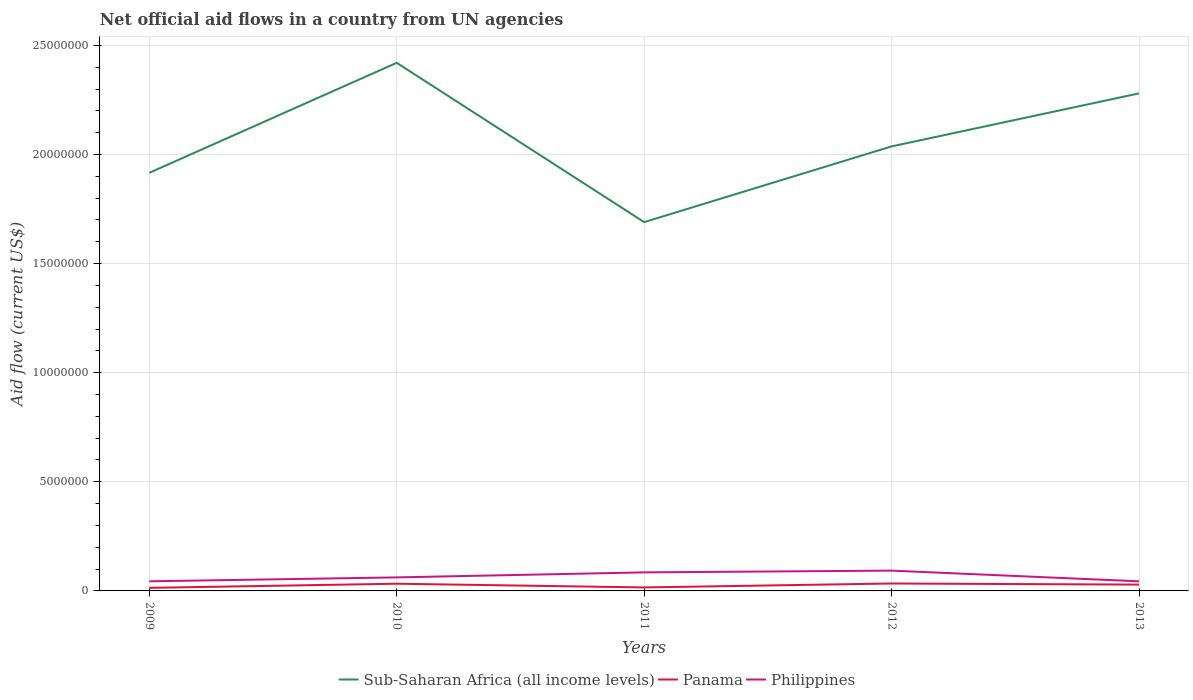How many different coloured lines are there?
Your response must be concise. 3. Does the line corresponding to Sub-Saharan Africa (all income levels) intersect with the line corresponding to Philippines?
Offer a very short reply. No. Is the number of lines equal to the number of legend labels?
Your response must be concise. Yes. Across all years, what is the maximum net official aid flow in Sub-Saharan Africa (all income levels)?
Provide a short and direct response. 1.69e+07. In which year was the net official aid flow in Sub-Saharan Africa (all income levels) maximum?
Your response must be concise. 2011. What is the total net official aid flow in Sub-Saharan Africa (all income levels) in the graph?
Provide a succinct answer. -1.21e+06. What is the difference between the highest and the second highest net official aid flow in Panama?
Offer a terse response. 2.00e+05. What is the difference between the highest and the lowest net official aid flow in Sub-Saharan Africa (all income levels)?
Your answer should be very brief. 2. Is the net official aid flow in Sub-Saharan Africa (all income levels) strictly greater than the net official aid flow in Philippines over the years?
Your answer should be compact. No. Are the values on the major ticks of Y-axis written in scientific E-notation?
Offer a terse response. No. Does the graph contain any zero values?
Provide a short and direct response. No. How many legend labels are there?
Provide a succinct answer. 3. How are the legend labels stacked?
Your answer should be very brief. Horizontal. What is the title of the graph?
Offer a terse response. Net official aid flows in a country from UN agencies. What is the label or title of the X-axis?
Give a very brief answer. Years. What is the label or title of the Y-axis?
Your response must be concise. Aid flow (current US$). What is the Aid flow (current US$) of Sub-Saharan Africa (all income levels) in 2009?
Offer a terse response. 1.92e+07. What is the Aid flow (current US$) in Panama in 2009?
Give a very brief answer. 1.40e+05. What is the Aid flow (current US$) of Philippines in 2009?
Offer a terse response. 4.40e+05. What is the Aid flow (current US$) in Sub-Saharan Africa (all income levels) in 2010?
Your answer should be compact. 2.42e+07. What is the Aid flow (current US$) of Philippines in 2010?
Your response must be concise. 6.20e+05. What is the Aid flow (current US$) in Sub-Saharan Africa (all income levels) in 2011?
Provide a short and direct response. 1.69e+07. What is the Aid flow (current US$) in Panama in 2011?
Provide a short and direct response. 1.60e+05. What is the Aid flow (current US$) of Philippines in 2011?
Ensure brevity in your answer.  8.50e+05. What is the Aid flow (current US$) in Sub-Saharan Africa (all income levels) in 2012?
Provide a short and direct response. 2.04e+07. What is the Aid flow (current US$) in Panama in 2012?
Ensure brevity in your answer.  3.40e+05. What is the Aid flow (current US$) in Philippines in 2012?
Your answer should be compact. 9.30e+05. What is the Aid flow (current US$) of Sub-Saharan Africa (all income levels) in 2013?
Provide a short and direct response. 2.28e+07. What is the Aid flow (current US$) of Panama in 2013?
Offer a very short reply. 2.90e+05. Across all years, what is the maximum Aid flow (current US$) of Sub-Saharan Africa (all income levels)?
Your answer should be compact. 2.42e+07. Across all years, what is the maximum Aid flow (current US$) in Philippines?
Your response must be concise. 9.30e+05. Across all years, what is the minimum Aid flow (current US$) of Sub-Saharan Africa (all income levels)?
Ensure brevity in your answer.  1.69e+07. Across all years, what is the minimum Aid flow (current US$) in Panama?
Provide a succinct answer. 1.40e+05. Across all years, what is the minimum Aid flow (current US$) in Philippines?
Keep it short and to the point. 4.40e+05. What is the total Aid flow (current US$) in Sub-Saharan Africa (all income levels) in the graph?
Provide a short and direct response. 1.03e+08. What is the total Aid flow (current US$) in Panama in the graph?
Your response must be concise. 1.26e+06. What is the total Aid flow (current US$) of Philippines in the graph?
Provide a succinct answer. 3.28e+06. What is the difference between the Aid flow (current US$) of Sub-Saharan Africa (all income levels) in 2009 and that in 2010?
Keep it short and to the point. -5.04e+06. What is the difference between the Aid flow (current US$) in Panama in 2009 and that in 2010?
Your answer should be compact. -1.90e+05. What is the difference between the Aid flow (current US$) of Sub-Saharan Africa (all income levels) in 2009 and that in 2011?
Ensure brevity in your answer.  2.26e+06. What is the difference between the Aid flow (current US$) in Philippines in 2009 and that in 2011?
Make the answer very short. -4.10e+05. What is the difference between the Aid flow (current US$) of Sub-Saharan Africa (all income levels) in 2009 and that in 2012?
Offer a very short reply. -1.21e+06. What is the difference between the Aid flow (current US$) of Philippines in 2009 and that in 2012?
Your answer should be compact. -4.90e+05. What is the difference between the Aid flow (current US$) in Sub-Saharan Africa (all income levels) in 2009 and that in 2013?
Provide a succinct answer. -3.64e+06. What is the difference between the Aid flow (current US$) of Sub-Saharan Africa (all income levels) in 2010 and that in 2011?
Keep it short and to the point. 7.30e+06. What is the difference between the Aid flow (current US$) in Sub-Saharan Africa (all income levels) in 2010 and that in 2012?
Your response must be concise. 3.83e+06. What is the difference between the Aid flow (current US$) in Philippines in 2010 and that in 2012?
Provide a short and direct response. -3.10e+05. What is the difference between the Aid flow (current US$) in Sub-Saharan Africa (all income levels) in 2010 and that in 2013?
Ensure brevity in your answer.  1.40e+06. What is the difference between the Aid flow (current US$) in Sub-Saharan Africa (all income levels) in 2011 and that in 2012?
Ensure brevity in your answer.  -3.47e+06. What is the difference between the Aid flow (current US$) in Panama in 2011 and that in 2012?
Your response must be concise. -1.80e+05. What is the difference between the Aid flow (current US$) of Philippines in 2011 and that in 2012?
Your response must be concise. -8.00e+04. What is the difference between the Aid flow (current US$) in Sub-Saharan Africa (all income levels) in 2011 and that in 2013?
Ensure brevity in your answer.  -5.90e+06. What is the difference between the Aid flow (current US$) in Philippines in 2011 and that in 2013?
Your answer should be compact. 4.10e+05. What is the difference between the Aid flow (current US$) of Sub-Saharan Africa (all income levels) in 2012 and that in 2013?
Provide a succinct answer. -2.43e+06. What is the difference between the Aid flow (current US$) in Panama in 2012 and that in 2013?
Provide a short and direct response. 5.00e+04. What is the difference between the Aid flow (current US$) in Philippines in 2012 and that in 2013?
Your response must be concise. 4.90e+05. What is the difference between the Aid flow (current US$) in Sub-Saharan Africa (all income levels) in 2009 and the Aid flow (current US$) in Panama in 2010?
Your answer should be very brief. 1.88e+07. What is the difference between the Aid flow (current US$) of Sub-Saharan Africa (all income levels) in 2009 and the Aid flow (current US$) of Philippines in 2010?
Your answer should be compact. 1.85e+07. What is the difference between the Aid flow (current US$) of Panama in 2009 and the Aid flow (current US$) of Philippines in 2010?
Offer a very short reply. -4.80e+05. What is the difference between the Aid flow (current US$) in Sub-Saharan Africa (all income levels) in 2009 and the Aid flow (current US$) in Panama in 2011?
Your answer should be compact. 1.90e+07. What is the difference between the Aid flow (current US$) of Sub-Saharan Africa (all income levels) in 2009 and the Aid flow (current US$) of Philippines in 2011?
Your response must be concise. 1.83e+07. What is the difference between the Aid flow (current US$) of Panama in 2009 and the Aid flow (current US$) of Philippines in 2011?
Provide a succinct answer. -7.10e+05. What is the difference between the Aid flow (current US$) in Sub-Saharan Africa (all income levels) in 2009 and the Aid flow (current US$) in Panama in 2012?
Offer a very short reply. 1.88e+07. What is the difference between the Aid flow (current US$) of Sub-Saharan Africa (all income levels) in 2009 and the Aid flow (current US$) of Philippines in 2012?
Ensure brevity in your answer.  1.82e+07. What is the difference between the Aid flow (current US$) of Panama in 2009 and the Aid flow (current US$) of Philippines in 2012?
Your answer should be compact. -7.90e+05. What is the difference between the Aid flow (current US$) of Sub-Saharan Africa (all income levels) in 2009 and the Aid flow (current US$) of Panama in 2013?
Your answer should be very brief. 1.89e+07. What is the difference between the Aid flow (current US$) of Sub-Saharan Africa (all income levels) in 2009 and the Aid flow (current US$) of Philippines in 2013?
Keep it short and to the point. 1.87e+07. What is the difference between the Aid flow (current US$) in Sub-Saharan Africa (all income levels) in 2010 and the Aid flow (current US$) in Panama in 2011?
Give a very brief answer. 2.40e+07. What is the difference between the Aid flow (current US$) in Sub-Saharan Africa (all income levels) in 2010 and the Aid flow (current US$) in Philippines in 2011?
Keep it short and to the point. 2.34e+07. What is the difference between the Aid flow (current US$) in Panama in 2010 and the Aid flow (current US$) in Philippines in 2011?
Make the answer very short. -5.20e+05. What is the difference between the Aid flow (current US$) of Sub-Saharan Africa (all income levels) in 2010 and the Aid flow (current US$) of Panama in 2012?
Offer a very short reply. 2.39e+07. What is the difference between the Aid flow (current US$) of Sub-Saharan Africa (all income levels) in 2010 and the Aid flow (current US$) of Philippines in 2012?
Provide a succinct answer. 2.33e+07. What is the difference between the Aid flow (current US$) in Panama in 2010 and the Aid flow (current US$) in Philippines in 2012?
Keep it short and to the point. -6.00e+05. What is the difference between the Aid flow (current US$) in Sub-Saharan Africa (all income levels) in 2010 and the Aid flow (current US$) in Panama in 2013?
Offer a terse response. 2.39e+07. What is the difference between the Aid flow (current US$) of Sub-Saharan Africa (all income levels) in 2010 and the Aid flow (current US$) of Philippines in 2013?
Your response must be concise. 2.38e+07. What is the difference between the Aid flow (current US$) in Sub-Saharan Africa (all income levels) in 2011 and the Aid flow (current US$) in Panama in 2012?
Offer a terse response. 1.66e+07. What is the difference between the Aid flow (current US$) of Sub-Saharan Africa (all income levels) in 2011 and the Aid flow (current US$) of Philippines in 2012?
Your answer should be very brief. 1.60e+07. What is the difference between the Aid flow (current US$) in Panama in 2011 and the Aid flow (current US$) in Philippines in 2012?
Offer a terse response. -7.70e+05. What is the difference between the Aid flow (current US$) of Sub-Saharan Africa (all income levels) in 2011 and the Aid flow (current US$) of Panama in 2013?
Keep it short and to the point. 1.66e+07. What is the difference between the Aid flow (current US$) in Sub-Saharan Africa (all income levels) in 2011 and the Aid flow (current US$) in Philippines in 2013?
Make the answer very short. 1.65e+07. What is the difference between the Aid flow (current US$) in Panama in 2011 and the Aid flow (current US$) in Philippines in 2013?
Provide a short and direct response. -2.80e+05. What is the difference between the Aid flow (current US$) in Sub-Saharan Africa (all income levels) in 2012 and the Aid flow (current US$) in Panama in 2013?
Offer a very short reply. 2.01e+07. What is the difference between the Aid flow (current US$) of Sub-Saharan Africa (all income levels) in 2012 and the Aid flow (current US$) of Philippines in 2013?
Your response must be concise. 1.99e+07. What is the difference between the Aid flow (current US$) of Panama in 2012 and the Aid flow (current US$) of Philippines in 2013?
Your response must be concise. -1.00e+05. What is the average Aid flow (current US$) in Sub-Saharan Africa (all income levels) per year?
Your response must be concise. 2.07e+07. What is the average Aid flow (current US$) in Panama per year?
Keep it short and to the point. 2.52e+05. What is the average Aid flow (current US$) in Philippines per year?
Offer a very short reply. 6.56e+05. In the year 2009, what is the difference between the Aid flow (current US$) of Sub-Saharan Africa (all income levels) and Aid flow (current US$) of Panama?
Your response must be concise. 1.90e+07. In the year 2009, what is the difference between the Aid flow (current US$) in Sub-Saharan Africa (all income levels) and Aid flow (current US$) in Philippines?
Ensure brevity in your answer.  1.87e+07. In the year 2009, what is the difference between the Aid flow (current US$) in Panama and Aid flow (current US$) in Philippines?
Your response must be concise. -3.00e+05. In the year 2010, what is the difference between the Aid flow (current US$) in Sub-Saharan Africa (all income levels) and Aid flow (current US$) in Panama?
Ensure brevity in your answer.  2.39e+07. In the year 2010, what is the difference between the Aid flow (current US$) of Sub-Saharan Africa (all income levels) and Aid flow (current US$) of Philippines?
Your answer should be compact. 2.36e+07. In the year 2010, what is the difference between the Aid flow (current US$) in Panama and Aid flow (current US$) in Philippines?
Your response must be concise. -2.90e+05. In the year 2011, what is the difference between the Aid flow (current US$) of Sub-Saharan Africa (all income levels) and Aid flow (current US$) of Panama?
Provide a succinct answer. 1.67e+07. In the year 2011, what is the difference between the Aid flow (current US$) in Sub-Saharan Africa (all income levels) and Aid flow (current US$) in Philippines?
Give a very brief answer. 1.60e+07. In the year 2011, what is the difference between the Aid flow (current US$) in Panama and Aid flow (current US$) in Philippines?
Your answer should be compact. -6.90e+05. In the year 2012, what is the difference between the Aid flow (current US$) of Sub-Saharan Africa (all income levels) and Aid flow (current US$) of Panama?
Offer a terse response. 2.00e+07. In the year 2012, what is the difference between the Aid flow (current US$) of Sub-Saharan Africa (all income levels) and Aid flow (current US$) of Philippines?
Offer a terse response. 1.94e+07. In the year 2012, what is the difference between the Aid flow (current US$) of Panama and Aid flow (current US$) of Philippines?
Your answer should be very brief. -5.90e+05. In the year 2013, what is the difference between the Aid flow (current US$) in Sub-Saharan Africa (all income levels) and Aid flow (current US$) in Panama?
Ensure brevity in your answer.  2.25e+07. In the year 2013, what is the difference between the Aid flow (current US$) of Sub-Saharan Africa (all income levels) and Aid flow (current US$) of Philippines?
Provide a short and direct response. 2.24e+07. In the year 2013, what is the difference between the Aid flow (current US$) of Panama and Aid flow (current US$) of Philippines?
Offer a terse response. -1.50e+05. What is the ratio of the Aid flow (current US$) in Sub-Saharan Africa (all income levels) in 2009 to that in 2010?
Provide a short and direct response. 0.79. What is the ratio of the Aid flow (current US$) in Panama in 2009 to that in 2010?
Your response must be concise. 0.42. What is the ratio of the Aid flow (current US$) of Philippines in 2009 to that in 2010?
Ensure brevity in your answer.  0.71. What is the ratio of the Aid flow (current US$) of Sub-Saharan Africa (all income levels) in 2009 to that in 2011?
Offer a very short reply. 1.13. What is the ratio of the Aid flow (current US$) in Panama in 2009 to that in 2011?
Offer a very short reply. 0.88. What is the ratio of the Aid flow (current US$) of Philippines in 2009 to that in 2011?
Give a very brief answer. 0.52. What is the ratio of the Aid flow (current US$) of Sub-Saharan Africa (all income levels) in 2009 to that in 2012?
Your answer should be compact. 0.94. What is the ratio of the Aid flow (current US$) in Panama in 2009 to that in 2012?
Provide a short and direct response. 0.41. What is the ratio of the Aid flow (current US$) in Philippines in 2009 to that in 2012?
Give a very brief answer. 0.47. What is the ratio of the Aid flow (current US$) in Sub-Saharan Africa (all income levels) in 2009 to that in 2013?
Keep it short and to the point. 0.84. What is the ratio of the Aid flow (current US$) in Panama in 2009 to that in 2013?
Offer a very short reply. 0.48. What is the ratio of the Aid flow (current US$) in Philippines in 2009 to that in 2013?
Provide a succinct answer. 1. What is the ratio of the Aid flow (current US$) in Sub-Saharan Africa (all income levels) in 2010 to that in 2011?
Offer a very short reply. 1.43. What is the ratio of the Aid flow (current US$) of Panama in 2010 to that in 2011?
Keep it short and to the point. 2.06. What is the ratio of the Aid flow (current US$) of Philippines in 2010 to that in 2011?
Offer a very short reply. 0.73. What is the ratio of the Aid flow (current US$) in Sub-Saharan Africa (all income levels) in 2010 to that in 2012?
Provide a succinct answer. 1.19. What is the ratio of the Aid flow (current US$) in Panama in 2010 to that in 2012?
Provide a short and direct response. 0.97. What is the ratio of the Aid flow (current US$) of Sub-Saharan Africa (all income levels) in 2010 to that in 2013?
Provide a succinct answer. 1.06. What is the ratio of the Aid flow (current US$) in Panama in 2010 to that in 2013?
Your response must be concise. 1.14. What is the ratio of the Aid flow (current US$) in Philippines in 2010 to that in 2013?
Offer a terse response. 1.41. What is the ratio of the Aid flow (current US$) in Sub-Saharan Africa (all income levels) in 2011 to that in 2012?
Provide a succinct answer. 0.83. What is the ratio of the Aid flow (current US$) in Panama in 2011 to that in 2012?
Provide a succinct answer. 0.47. What is the ratio of the Aid flow (current US$) of Philippines in 2011 to that in 2012?
Offer a terse response. 0.91. What is the ratio of the Aid flow (current US$) of Sub-Saharan Africa (all income levels) in 2011 to that in 2013?
Make the answer very short. 0.74. What is the ratio of the Aid flow (current US$) of Panama in 2011 to that in 2013?
Provide a short and direct response. 0.55. What is the ratio of the Aid flow (current US$) in Philippines in 2011 to that in 2013?
Ensure brevity in your answer.  1.93. What is the ratio of the Aid flow (current US$) in Sub-Saharan Africa (all income levels) in 2012 to that in 2013?
Ensure brevity in your answer.  0.89. What is the ratio of the Aid flow (current US$) in Panama in 2012 to that in 2013?
Provide a succinct answer. 1.17. What is the ratio of the Aid flow (current US$) in Philippines in 2012 to that in 2013?
Your answer should be very brief. 2.11. What is the difference between the highest and the second highest Aid flow (current US$) in Sub-Saharan Africa (all income levels)?
Offer a very short reply. 1.40e+06. What is the difference between the highest and the second highest Aid flow (current US$) of Philippines?
Give a very brief answer. 8.00e+04. What is the difference between the highest and the lowest Aid flow (current US$) of Sub-Saharan Africa (all income levels)?
Your response must be concise. 7.30e+06. What is the difference between the highest and the lowest Aid flow (current US$) in Philippines?
Offer a terse response. 4.90e+05. 